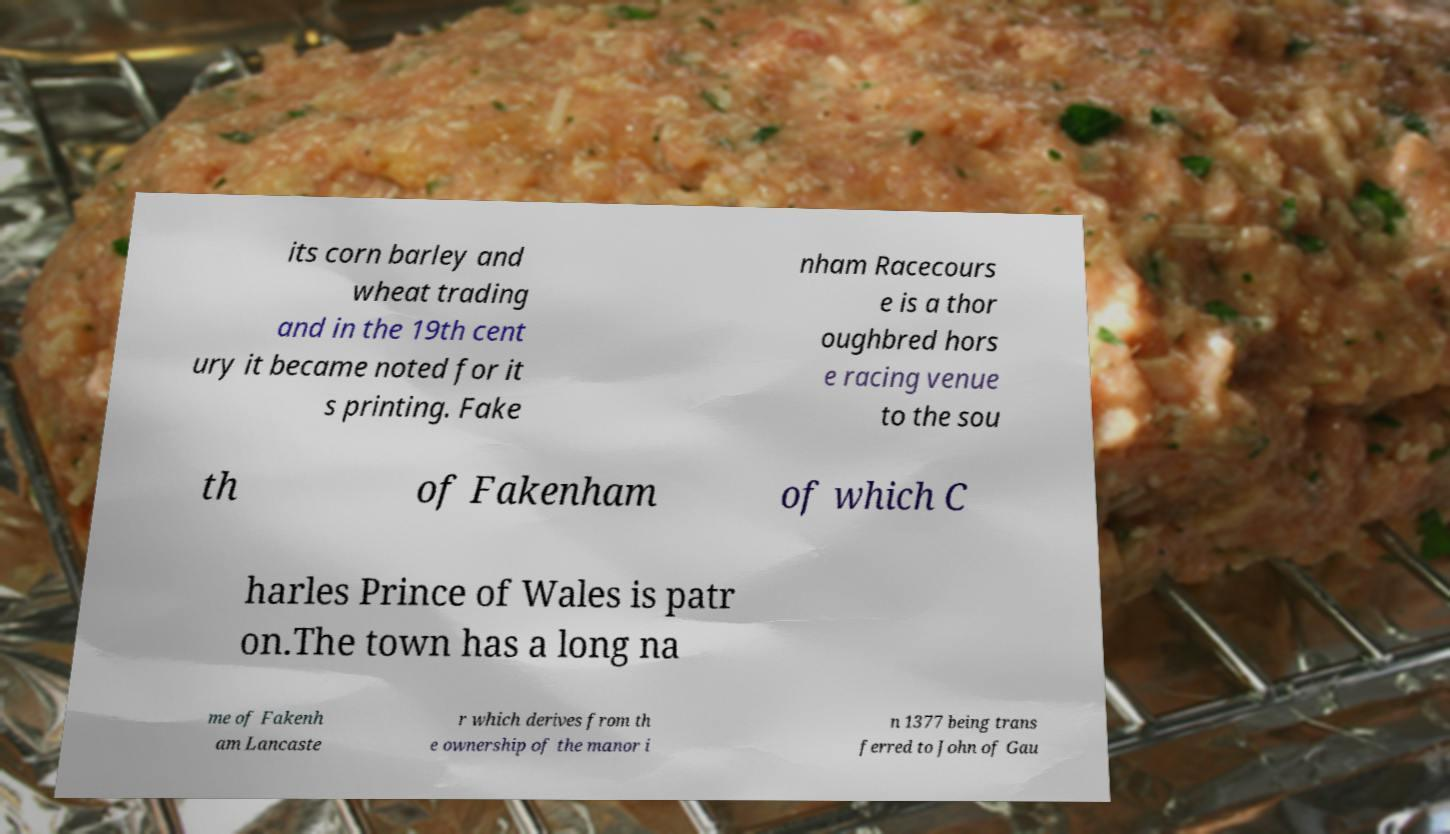Please identify and transcribe the text found in this image. its corn barley and wheat trading and in the 19th cent ury it became noted for it s printing. Fake nham Racecours e is a thor oughbred hors e racing venue to the sou th of Fakenham of which C harles Prince of Wales is patr on.The town has a long na me of Fakenh am Lancaste r which derives from th e ownership of the manor i n 1377 being trans ferred to John of Gau 